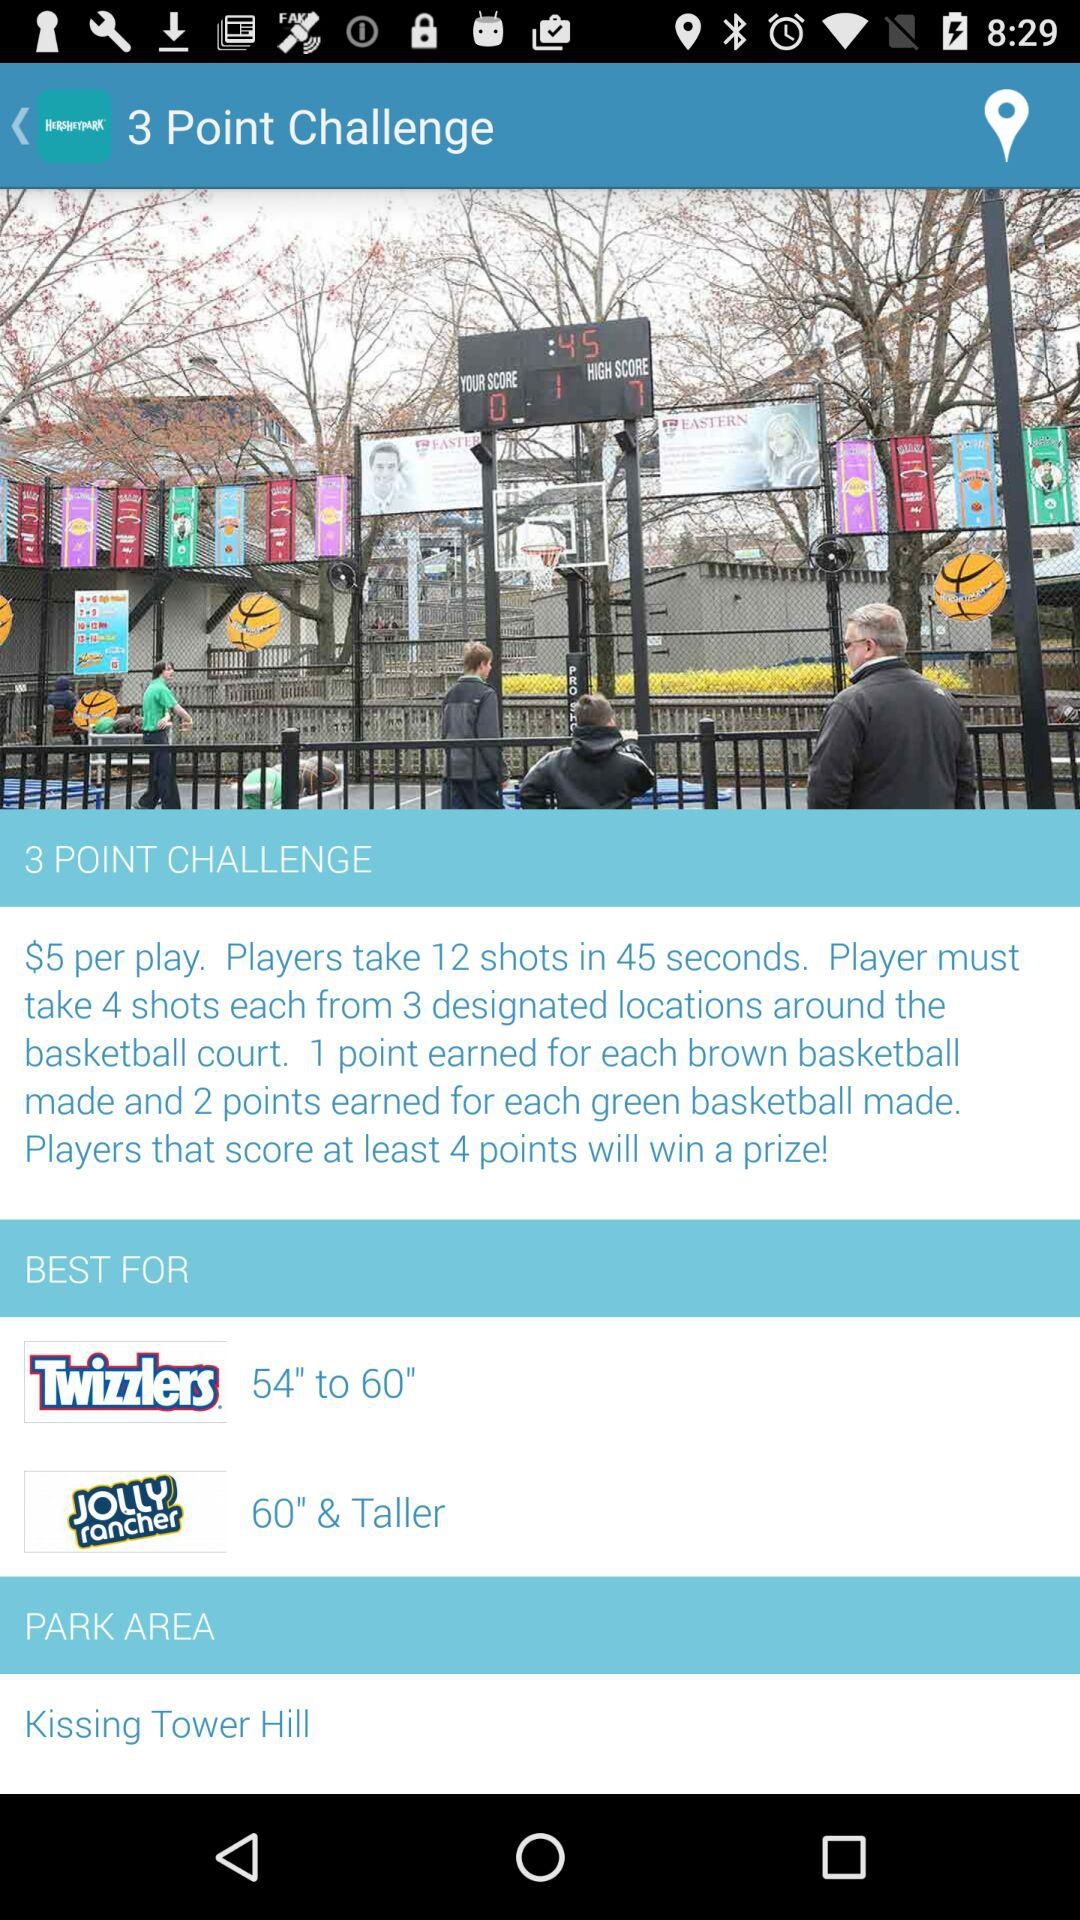What is the application name? The application name is "3 Point Challenge". 